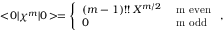Convert formula to latex. <formula><loc_0><loc_0><loc_500><loc_500>< \, 0 | \chi ^ { m } | 0 \, > = \left \{ \begin{array} { l l } { { ( m - 1 ) ! ! \, X ^ { m / 2 } } } & { m e v e n } \\ { 0 } & { m o d d } \end{array} ,</formula> 